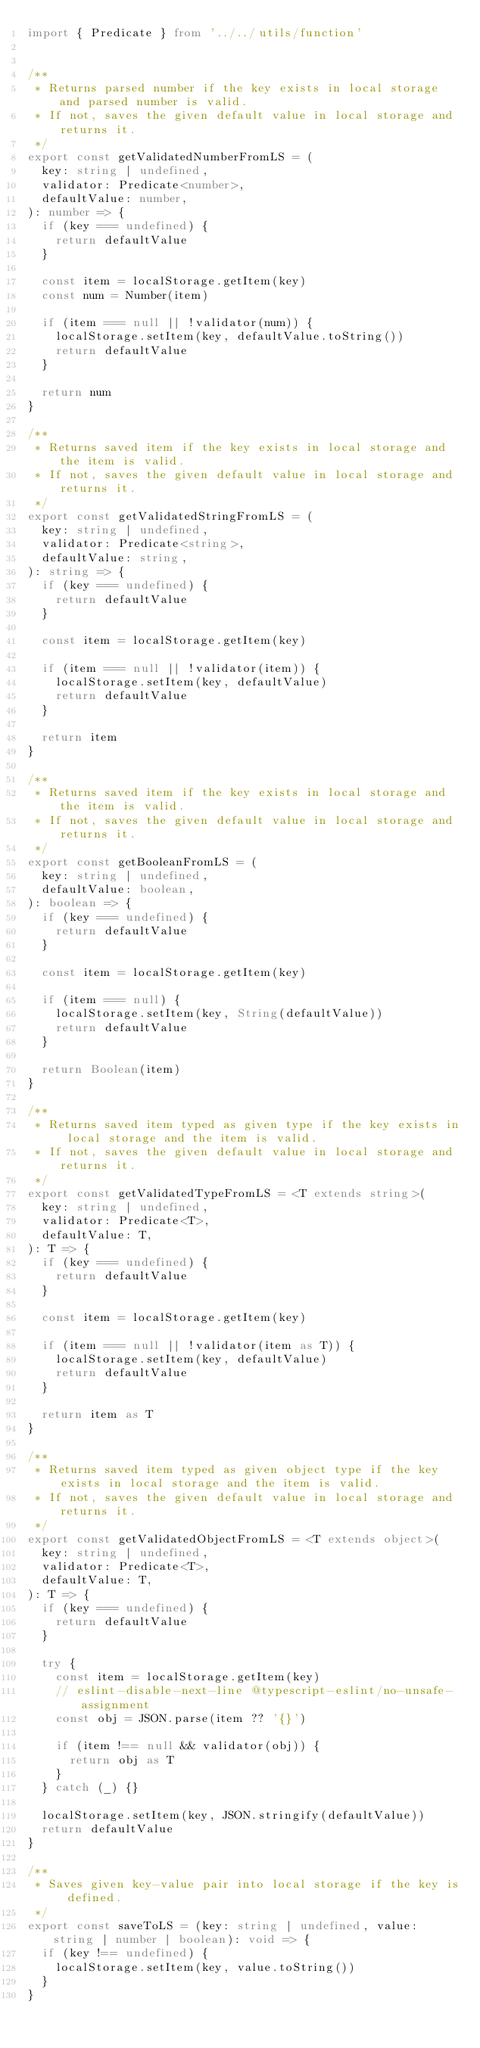<code> <loc_0><loc_0><loc_500><loc_500><_TypeScript_>import { Predicate } from '../../utils/function'


/**
 * Returns parsed number if the key exists in local storage and parsed number is valid.
 * If not, saves the given default value in local storage and returns it.
 */
export const getValidatedNumberFromLS = (
  key: string | undefined,
  validator: Predicate<number>,
  defaultValue: number,
): number => {
  if (key === undefined) {
    return defaultValue
  }

  const item = localStorage.getItem(key)
  const num = Number(item)

  if (item === null || !validator(num)) {
    localStorage.setItem(key, defaultValue.toString())
    return defaultValue
  }

  return num
}

/**
 * Returns saved item if the key exists in local storage and the item is valid.
 * If not, saves the given default value in local storage and returns it.
 */
export const getValidatedStringFromLS = (
  key: string | undefined,
  validator: Predicate<string>,
  defaultValue: string,
): string => {
  if (key === undefined) {
    return defaultValue
  }

  const item = localStorage.getItem(key)

  if (item === null || !validator(item)) {
    localStorage.setItem(key, defaultValue)
    return defaultValue
  }

  return item
}

/**
 * Returns saved item if the key exists in local storage and the item is valid.
 * If not, saves the given default value in local storage and returns it.
 */
export const getBooleanFromLS = (
  key: string | undefined,
  defaultValue: boolean,
): boolean => {
  if (key === undefined) {
    return defaultValue
  }

  const item = localStorage.getItem(key)

  if (item === null) {
    localStorage.setItem(key, String(defaultValue))
    return defaultValue
  }

  return Boolean(item)
}

/**
 * Returns saved item typed as given type if the key exists in local storage and the item is valid.
 * If not, saves the given default value in local storage and returns it.
 */
export const getValidatedTypeFromLS = <T extends string>(
  key: string | undefined,
  validator: Predicate<T>,
  defaultValue: T,
): T => {
  if (key === undefined) {
    return defaultValue
  }

  const item = localStorage.getItem(key)

  if (item === null || !validator(item as T)) {
    localStorage.setItem(key, defaultValue)
    return defaultValue
  }

  return item as T
}

/**
 * Returns saved item typed as given object type if the key exists in local storage and the item is valid.
 * If not, saves the given default value in local storage and returns it.
 */
export const getValidatedObjectFromLS = <T extends object>(
  key: string | undefined,
  validator: Predicate<T>,
  defaultValue: T,
): T => {
  if (key === undefined) {
    return defaultValue
  }

  try {
    const item = localStorage.getItem(key)
    // eslint-disable-next-line @typescript-eslint/no-unsafe-assignment
    const obj = JSON.parse(item ?? '{}')

    if (item !== null && validator(obj)) {
      return obj as T
    }
  } catch (_) {}

  localStorage.setItem(key, JSON.stringify(defaultValue))
  return defaultValue
}

/**
 * Saves given key-value pair into local storage if the key is defined.
 */
export const saveToLS = (key: string | undefined, value: string | number | boolean): void => {
  if (key !== undefined) {
    localStorage.setItem(key, value.toString())
  }
}
</code> 